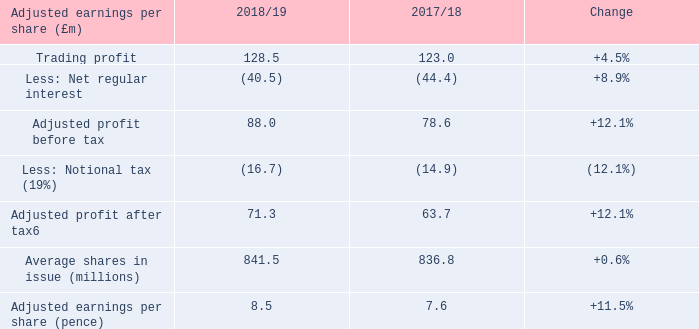The Group reported a loss before tax of £(42.7)m in the year, compared to a profit before tax of £20.9m in 2017/18. A loss after tax was £(33.8)m, compared to a £7.2m profit in the prior year.
Adjusted profit before tax was £88.0m in the year, an increase of £9.4m compared to the prior year due to growth both in Trading profit and lower interest costs as described above. Adjusted profit after tax increased £7.6m to £71.3m in the year after deducting a notional 19.0% tax charge of £16.7m. Based on average shares in issue of 841.5 million shares, adjusted earnings per share in the year was 8.5 pence, growth in the year of +11.5%.
What was the loss before tax reported in the year? £(42.7)m. What was the adjusted profit before tax in the year? £88.0m. What was the increase in the adjusted profit after tax? £7.6m. What was the average trading profit for 2017/18 and 2018/19?
Answer scale should be: million. (128.5 + 123.0) / 2
Answer: 125.75. What is the change in the adjusted profit before tax from 2017/18 to 2018/19?
Answer scale should be: million. 88.0 - 78.6
Answer: 9.4. What is the average notional tax for 2017/18 and 2018/19?
Answer scale should be: million. -(16.7 + 14.9) / 2
Answer: -15.8. 